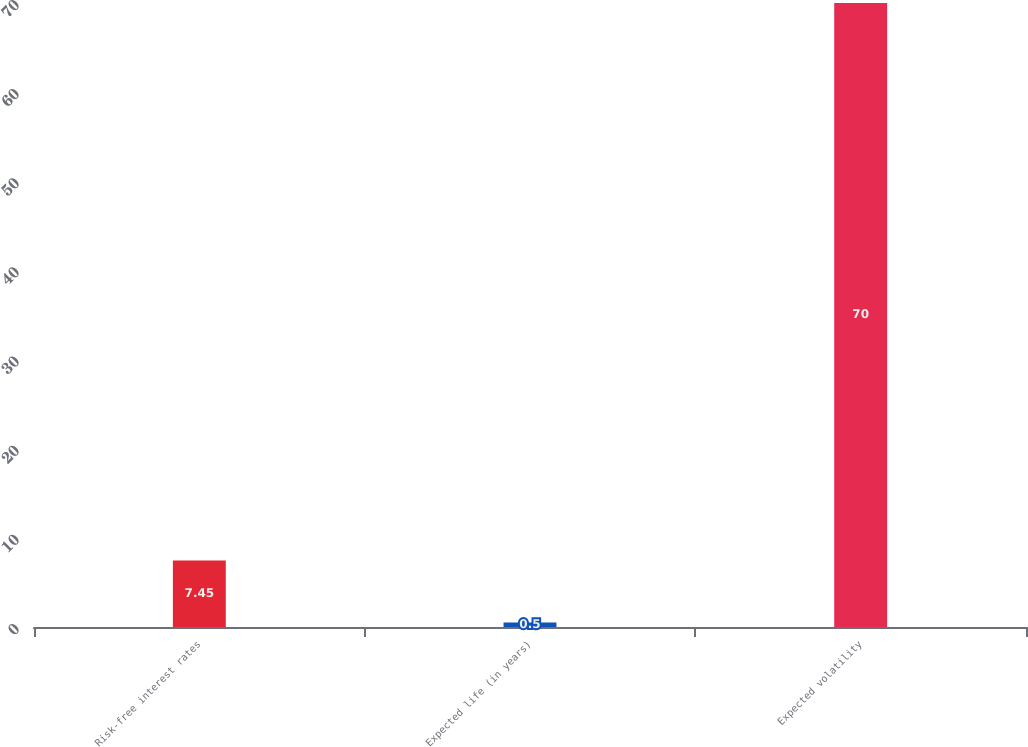Convert chart to OTSL. <chart><loc_0><loc_0><loc_500><loc_500><bar_chart><fcel>Risk-free interest rates<fcel>Expected life (in years)<fcel>Expected volatility<nl><fcel>7.45<fcel>0.5<fcel>70<nl></chart> 